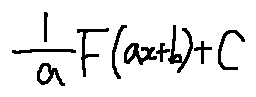Convert formula to latex. <formula><loc_0><loc_0><loc_500><loc_500>\frac { 1 } { a } F ( a x + b ) + C</formula> 